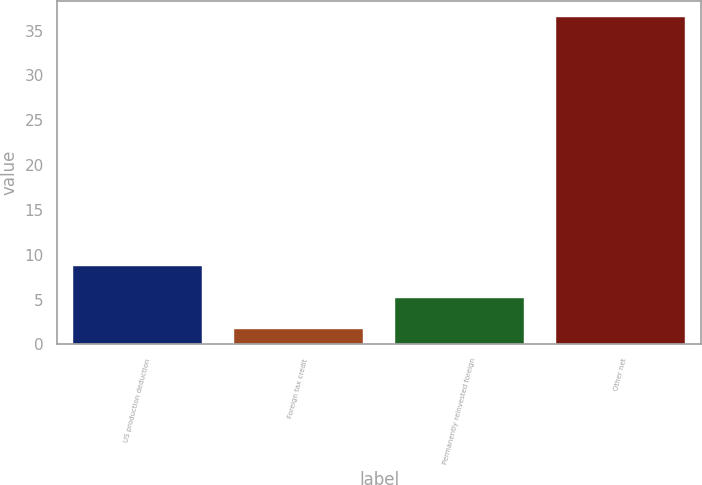Convert chart. <chart><loc_0><loc_0><loc_500><loc_500><bar_chart><fcel>US production deduction<fcel>Foreign tax credit<fcel>Permanently reinvested foreign<fcel>Other net<nl><fcel>8.7<fcel>1.75<fcel>5.22<fcel>36.5<nl></chart> 